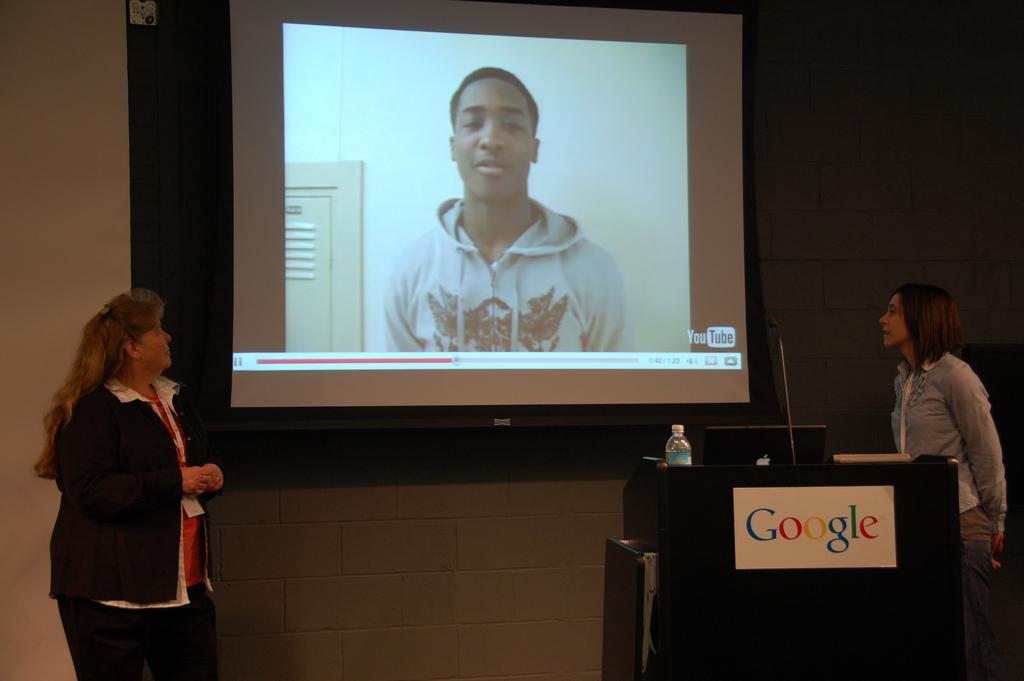Can you describe this image briefly? In this image there are two women standing on the stage, behind them there is a screen on the wall, in front of them on the dais there is a nameplate, mic, a bottle of water and some papers. 